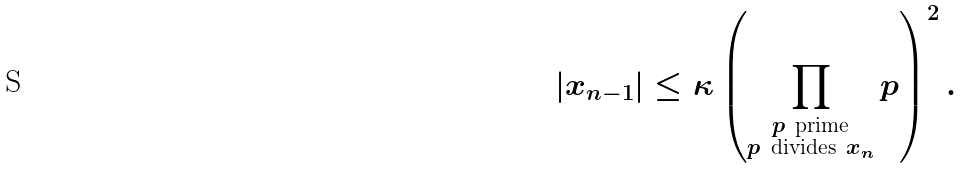<formula> <loc_0><loc_0><loc_500><loc_500>| x _ { n - 1 } | \leq \kappa \left ( \prod _ { \substack { p \ \text {prime} \\ p \ \text {divides} \ x _ { n } } } p \right ) ^ { 2 } .</formula> 